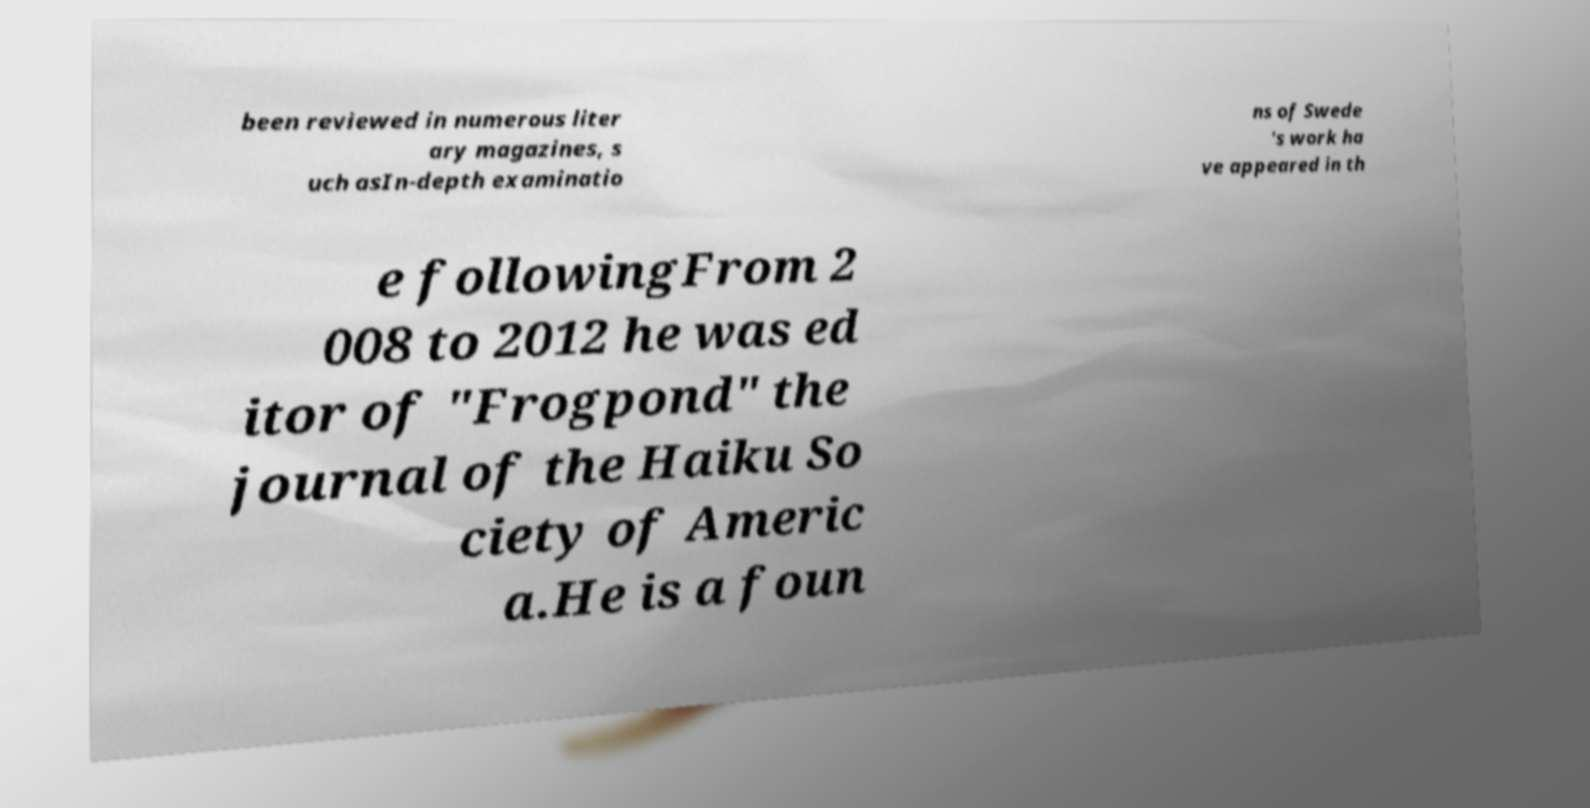For documentation purposes, I need the text within this image transcribed. Could you provide that? been reviewed in numerous liter ary magazines, s uch asIn-depth examinatio ns of Swede 's work ha ve appeared in th e followingFrom 2 008 to 2012 he was ed itor of "Frogpond" the journal of the Haiku So ciety of Americ a.He is a foun 